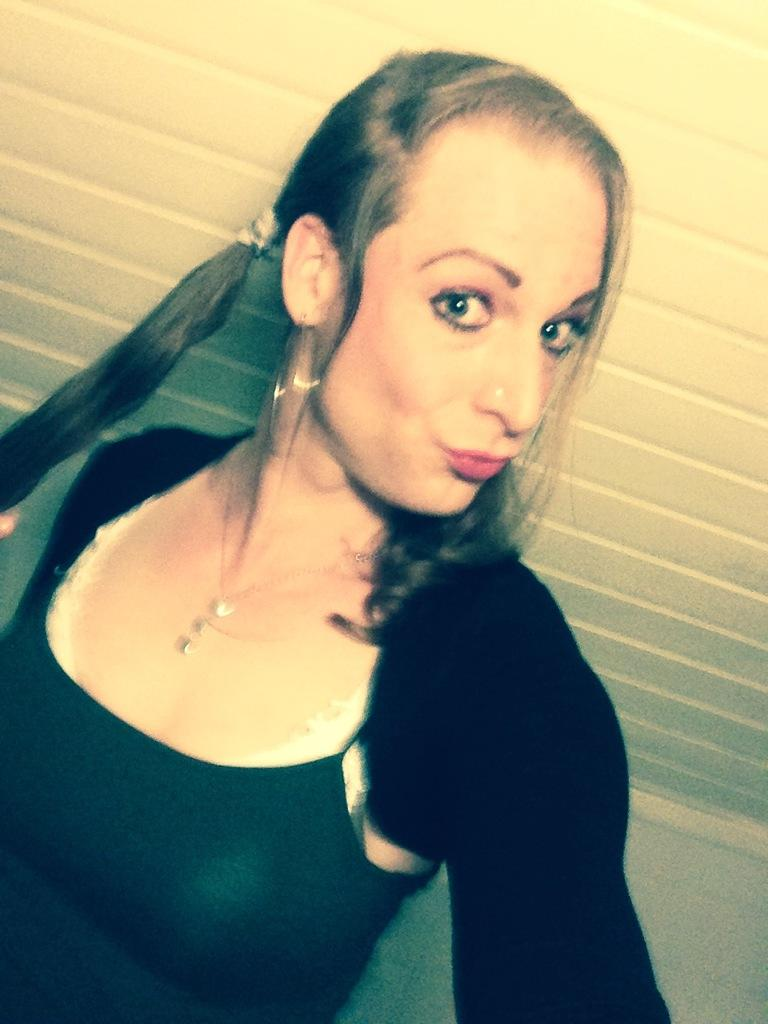Who is present in the image? There is a woman in the image. What is the woman wearing? The woman is wearing a black dress. What can be seen in the background of the image? There is a wall in the background of the image. What type of hose is the woman using to exchange brake fluid in the image? There is no hose, exchange, or brake fluid present in the image. 